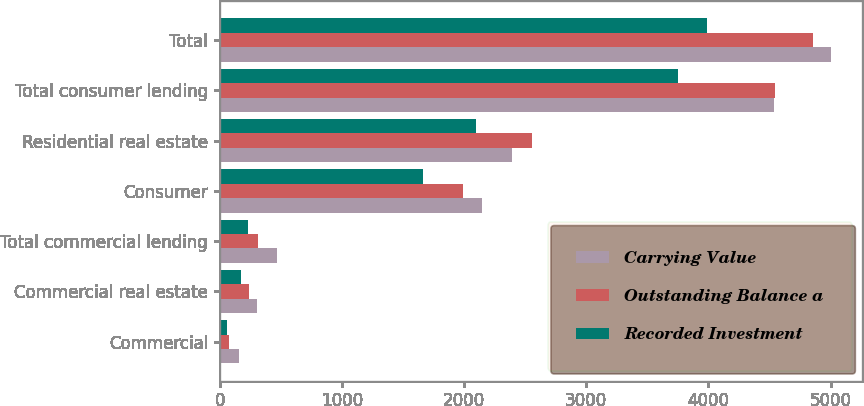<chart> <loc_0><loc_0><loc_500><loc_500><stacked_bar_chart><ecel><fcel>Commercial<fcel>Commercial real estate<fcel>Total commercial lending<fcel>Consumer<fcel>Residential real estate<fcel>Total consumer lending<fcel>Total<nl><fcel>Carrying Value<fcel>159<fcel>307<fcel>466<fcel>2145<fcel>2396<fcel>4541<fcel>5007<nl><fcel>Outstanding Balance a<fcel>74<fcel>236<fcel>310<fcel>1989<fcel>2559<fcel>4548<fcel>4858<nl><fcel>Recorded Investment<fcel>57<fcel>174<fcel>231<fcel>1661<fcel>2094<fcel>3755<fcel>3986<nl></chart> 